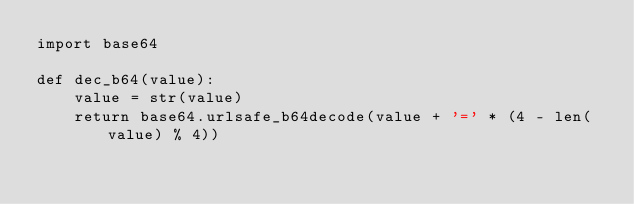<code> <loc_0><loc_0><loc_500><loc_500><_Python_>import base64

def dec_b64(value):
    value = str(value)
    return base64.urlsafe_b64decode(value + '=' * (4 - len(value) % 4))</code> 